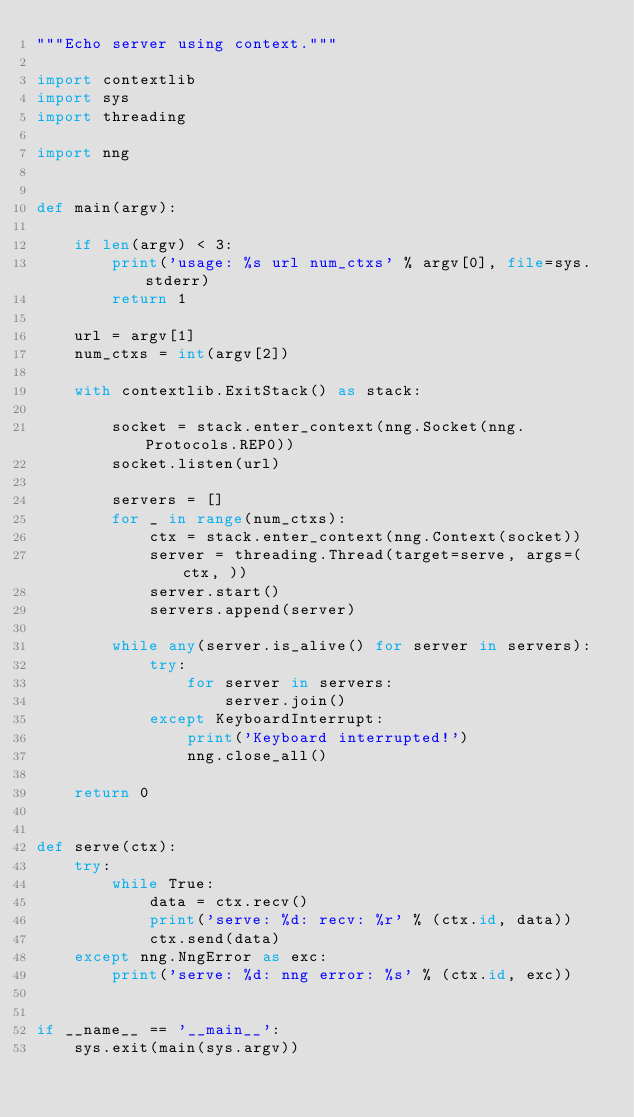Convert code to text. <code><loc_0><loc_0><loc_500><loc_500><_Python_>"""Echo server using context."""

import contextlib
import sys
import threading

import nng


def main(argv):

    if len(argv) < 3:
        print('usage: %s url num_ctxs' % argv[0], file=sys.stderr)
        return 1

    url = argv[1]
    num_ctxs = int(argv[2])

    with contextlib.ExitStack() as stack:

        socket = stack.enter_context(nng.Socket(nng.Protocols.REP0))
        socket.listen(url)

        servers = []
        for _ in range(num_ctxs):
            ctx = stack.enter_context(nng.Context(socket))
            server = threading.Thread(target=serve, args=(ctx, ))
            server.start()
            servers.append(server)

        while any(server.is_alive() for server in servers):
            try:
                for server in servers:
                    server.join()
            except KeyboardInterrupt:
                print('Keyboard interrupted!')
                nng.close_all()

    return 0


def serve(ctx):
    try:
        while True:
            data = ctx.recv()
            print('serve: %d: recv: %r' % (ctx.id, data))
            ctx.send(data)
    except nng.NngError as exc:
        print('serve: %d: nng error: %s' % (ctx.id, exc))


if __name__ == '__main__':
    sys.exit(main(sys.argv))
</code> 